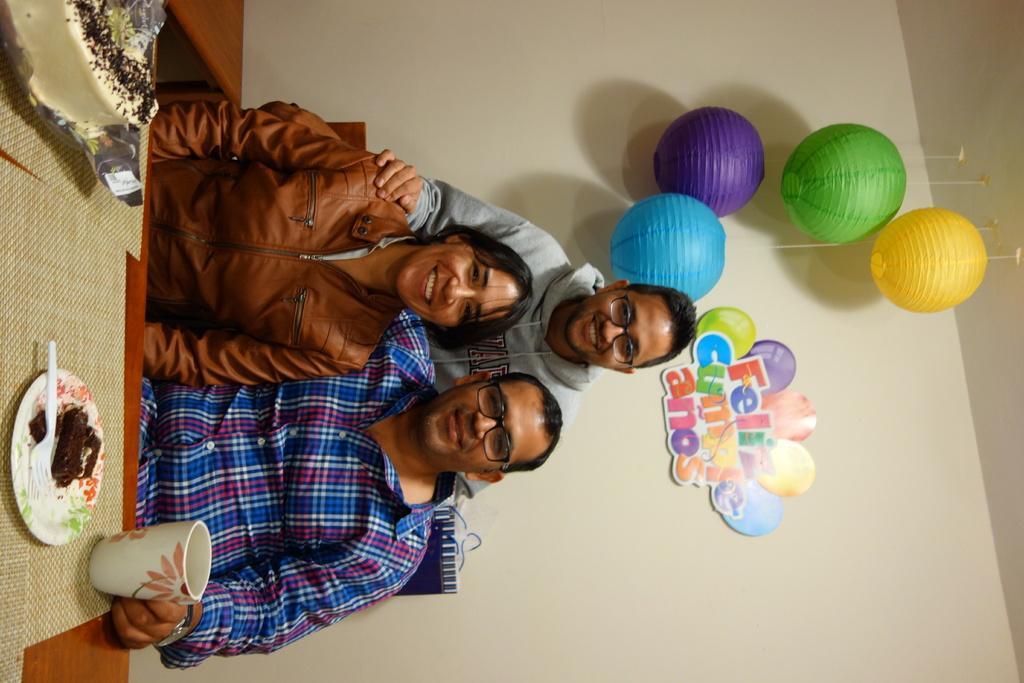How would you summarize this image in a sentence or two? In this picture, we see two people are sitting on the chairs. Behind them, we see a man is standing. Three of them are smiling and they might be posing for the photo. In front of them, we see a table on which cake, a plate containing cake, spoon and a cup are placed. Beside them, we see a brown table. In the background, we see a wall and the lanterns. We see something which looks like a sticker is placed on the white wall. 